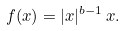<formula> <loc_0><loc_0><loc_500><loc_500>f ( x ) = | x | ^ { b - 1 } \, x .</formula> 